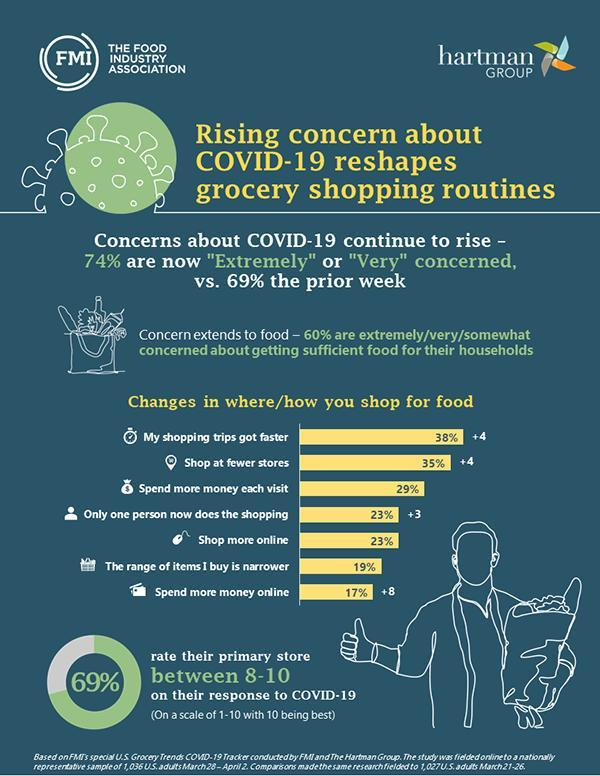What percent of people rate their primary store below 8 on their response to COVID-19?
Answer the question with a short phrase. 31% What percent of people shop at fewer stores and shop more online? 58% 